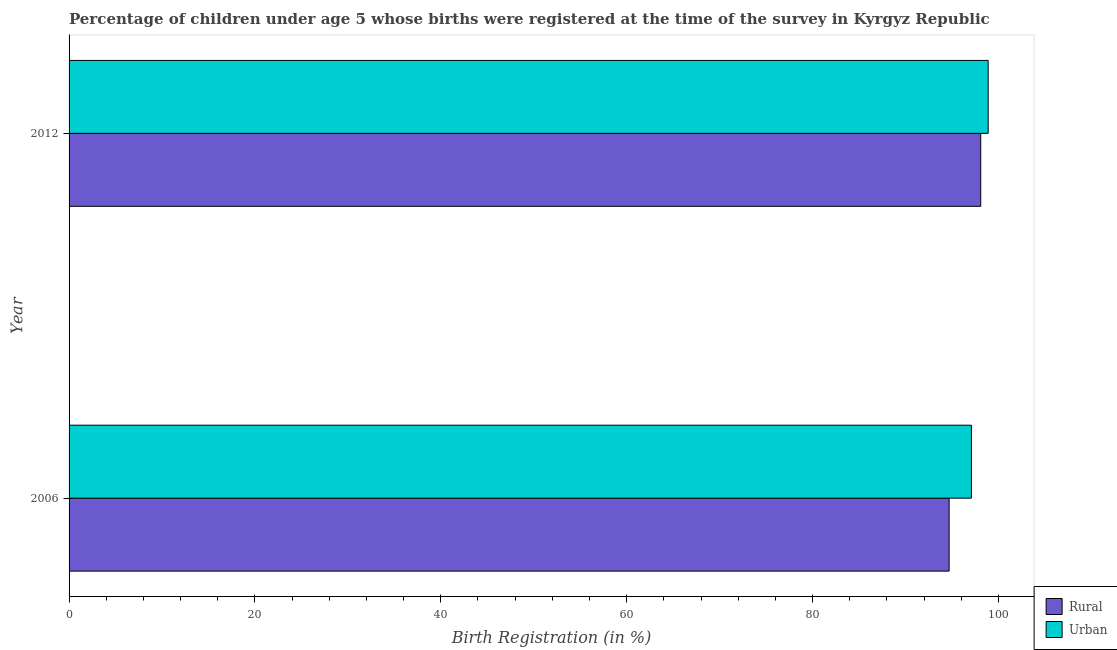How many groups of bars are there?
Your response must be concise. 2. Are the number of bars per tick equal to the number of legend labels?
Your response must be concise. Yes. How many bars are there on the 1st tick from the top?
Give a very brief answer. 2. How many bars are there on the 1st tick from the bottom?
Your response must be concise. 2. In how many cases, is the number of bars for a given year not equal to the number of legend labels?
Offer a terse response. 0. What is the rural birth registration in 2006?
Provide a succinct answer. 94.7. Across all years, what is the maximum urban birth registration?
Your answer should be compact. 98.9. Across all years, what is the minimum urban birth registration?
Offer a very short reply. 97.1. In which year was the rural birth registration maximum?
Make the answer very short. 2012. In which year was the urban birth registration minimum?
Your answer should be compact. 2006. What is the total urban birth registration in the graph?
Make the answer very short. 196. What is the difference between the urban birth registration in 2006 and that in 2012?
Your answer should be compact. -1.8. What is the difference between the urban birth registration in 2006 and the rural birth registration in 2012?
Your response must be concise. -1. In how many years, is the rural birth registration greater than 64 %?
Offer a terse response. 2. What is the ratio of the urban birth registration in 2006 to that in 2012?
Give a very brief answer. 0.98. In how many years, is the rural birth registration greater than the average rural birth registration taken over all years?
Give a very brief answer. 1. What does the 2nd bar from the top in 2006 represents?
Give a very brief answer. Rural. What does the 2nd bar from the bottom in 2012 represents?
Make the answer very short. Urban. Are all the bars in the graph horizontal?
Provide a short and direct response. Yes. How many years are there in the graph?
Your response must be concise. 2. Does the graph contain any zero values?
Keep it short and to the point. No. How many legend labels are there?
Provide a short and direct response. 2. How are the legend labels stacked?
Give a very brief answer. Vertical. What is the title of the graph?
Offer a very short reply. Percentage of children under age 5 whose births were registered at the time of the survey in Kyrgyz Republic. Does "Export" appear as one of the legend labels in the graph?
Give a very brief answer. No. What is the label or title of the X-axis?
Provide a short and direct response. Birth Registration (in %). What is the label or title of the Y-axis?
Give a very brief answer. Year. What is the Birth Registration (in %) of Rural in 2006?
Give a very brief answer. 94.7. What is the Birth Registration (in %) in Urban in 2006?
Your response must be concise. 97.1. What is the Birth Registration (in %) of Rural in 2012?
Ensure brevity in your answer.  98.1. What is the Birth Registration (in %) in Urban in 2012?
Offer a terse response. 98.9. Across all years, what is the maximum Birth Registration (in %) of Rural?
Give a very brief answer. 98.1. Across all years, what is the maximum Birth Registration (in %) in Urban?
Your answer should be compact. 98.9. Across all years, what is the minimum Birth Registration (in %) of Rural?
Keep it short and to the point. 94.7. Across all years, what is the minimum Birth Registration (in %) in Urban?
Your answer should be very brief. 97.1. What is the total Birth Registration (in %) of Rural in the graph?
Provide a short and direct response. 192.8. What is the total Birth Registration (in %) in Urban in the graph?
Your response must be concise. 196. What is the difference between the Birth Registration (in %) in Urban in 2006 and that in 2012?
Make the answer very short. -1.8. What is the average Birth Registration (in %) in Rural per year?
Give a very brief answer. 96.4. In the year 2006, what is the difference between the Birth Registration (in %) of Rural and Birth Registration (in %) of Urban?
Your answer should be compact. -2.4. In the year 2012, what is the difference between the Birth Registration (in %) in Rural and Birth Registration (in %) in Urban?
Your answer should be very brief. -0.8. What is the ratio of the Birth Registration (in %) of Rural in 2006 to that in 2012?
Keep it short and to the point. 0.97. What is the ratio of the Birth Registration (in %) in Urban in 2006 to that in 2012?
Give a very brief answer. 0.98. What is the difference between the highest and the second highest Birth Registration (in %) of Rural?
Make the answer very short. 3.4. What is the difference between the highest and the second highest Birth Registration (in %) of Urban?
Ensure brevity in your answer.  1.8. 